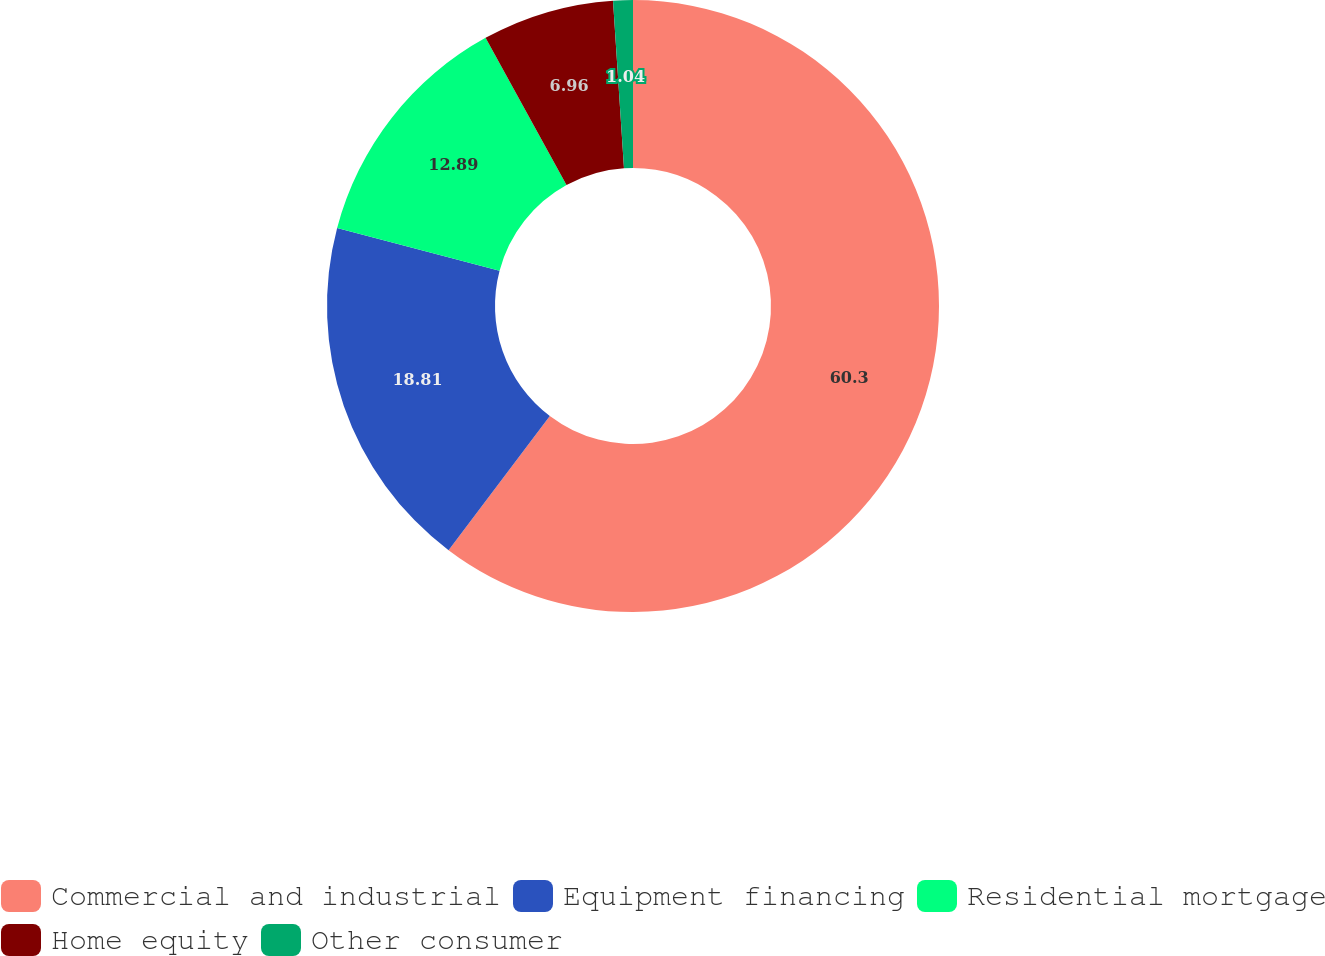Convert chart. <chart><loc_0><loc_0><loc_500><loc_500><pie_chart><fcel>Commercial and industrial<fcel>Equipment financing<fcel>Residential mortgage<fcel>Home equity<fcel>Other consumer<nl><fcel>60.29%<fcel>18.81%<fcel>12.89%<fcel>6.96%<fcel>1.04%<nl></chart> 